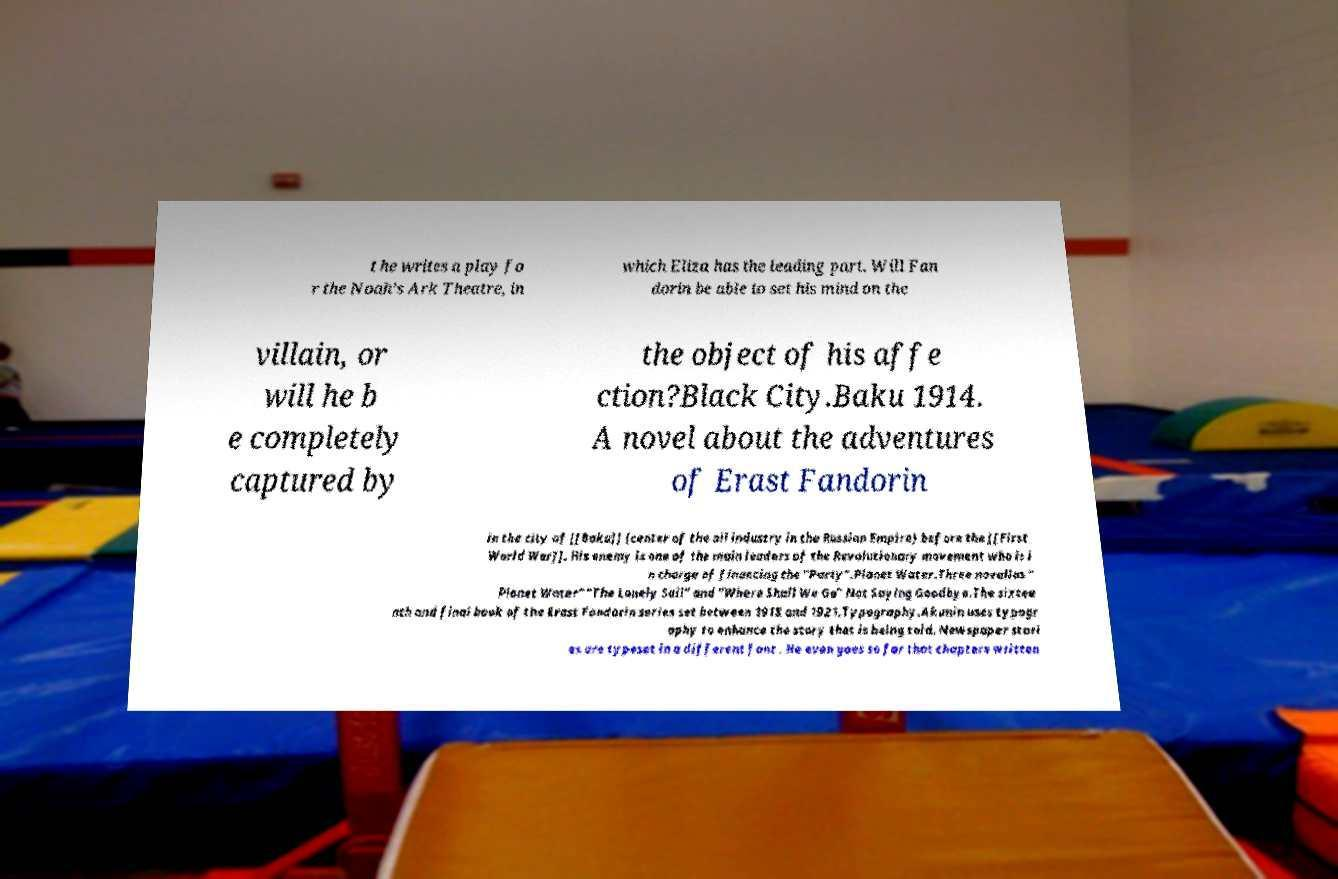Please read and relay the text visible in this image. What does it say? t he writes a play fo r the Noah's Ark Theatre, in which Eliza has the leading part. Will Fan dorin be able to set his mind on the villain, or will he b e completely captured by the object of his affe ction?Black City.Baku 1914. A novel about the adventures of Erast Fandorin in the city of [[Baku]] (center of the oil industry in the Russian Empire) before the [[First World War]]. His enemy is one of the main leaders of the Revolutionary movement who is i n charge of financing the "Party".Planet Water.Three novellas " Planet Water" "The Lonely Sail" and "Where Shall We Go" Not Saying Goodbye.The sixtee nth and final book of the Erast Fandorin series set between 1918 and 1921.Typography.Akunin uses typogr aphy to enhance the story that is being told. Newspaper stori es are typeset in a different font . He even goes so far that chapters written 